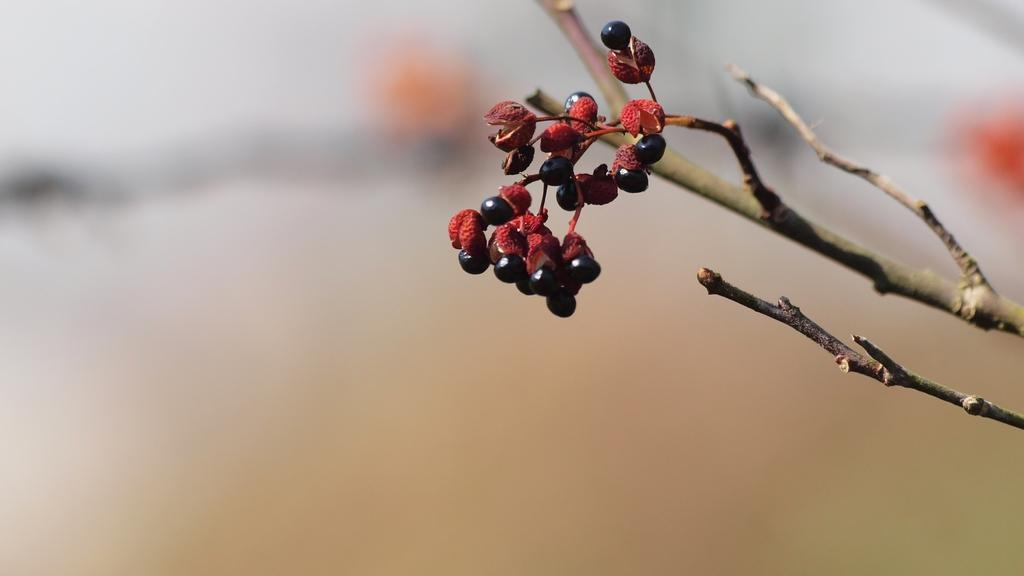What type of fruit or vegetable is present in the image? There are berries in the image. What else can be seen in the image besides the berries? There are branches visible in the image. How would you describe the background of the image? The background of the image is blurred. Can you see a sock hanging from one of the branches in the image? There is no sock present in the image. What shape is formed by the arrangement of the berries in the image? The arrangement of the berries does not form a specific shape like a circle. 